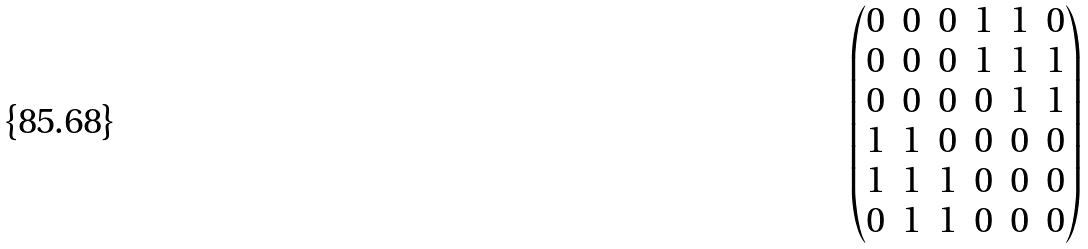<formula> <loc_0><loc_0><loc_500><loc_500>\begin{pmatrix} 0 & 0 & 0 & 1 & 1 & 0 \\ 0 & 0 & 0 & 1 & 1 & 1 \\ 0 & 0 & 0 & 0 & 1 & 1 \\ 1 & 1 & 0 & 0 & 0 & 0 \\ 1 & 1 & 1 & 0 & 0 & 0 \\ 0 & 1 & 1 & 0 & 0 & 0 \end{pmatrix}</formula> 